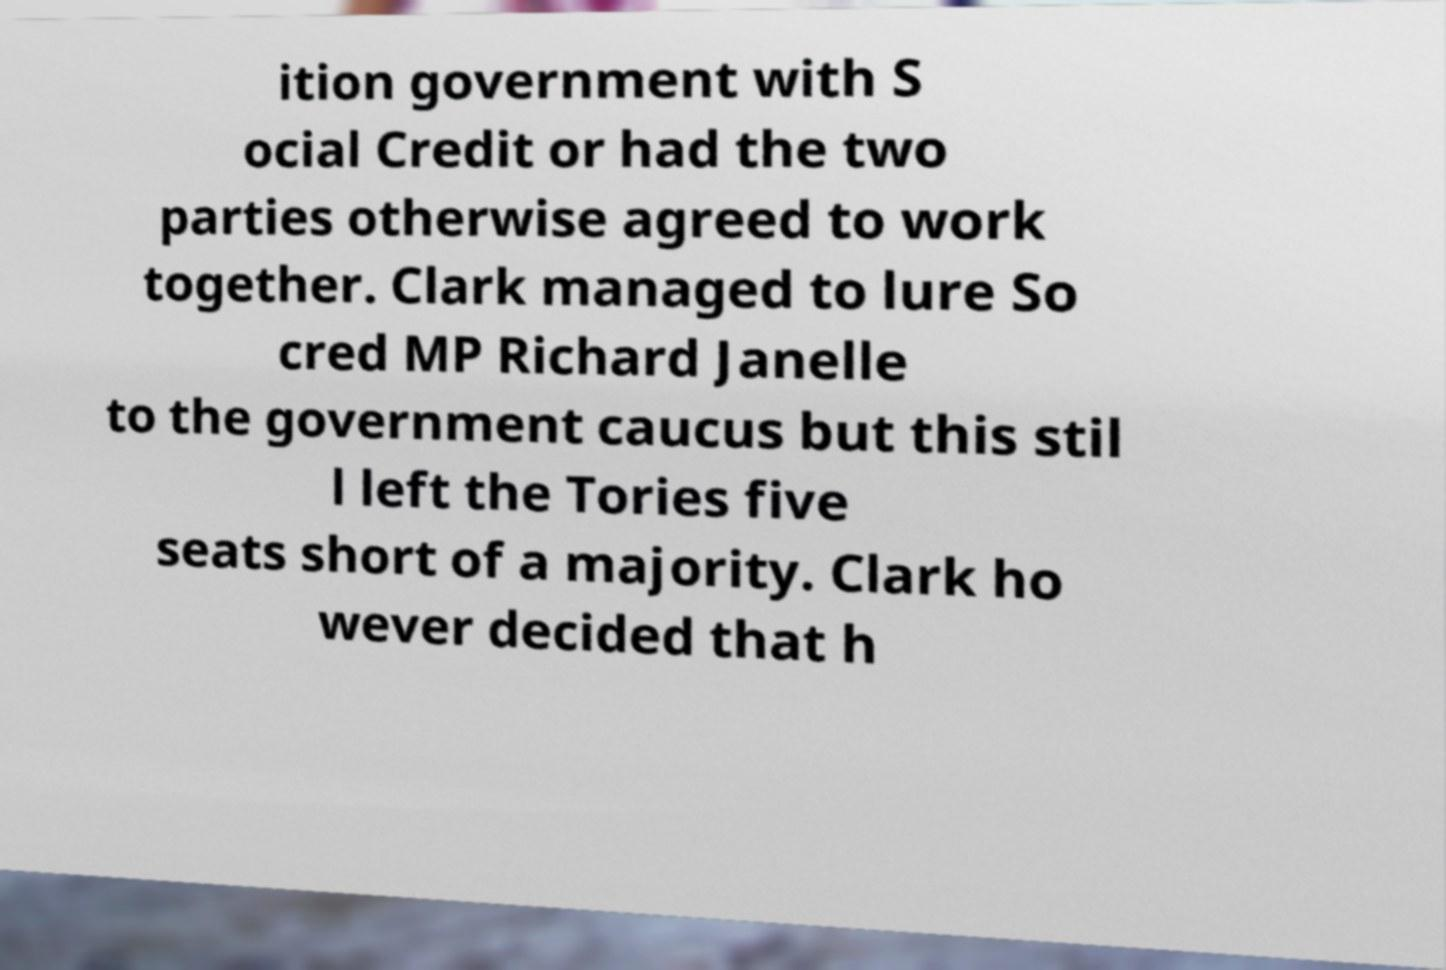I need the written content from this picture converted into text. Can you do that? ition government with S ocial Credit or had the two parties otherwise agreed to work together. Clark managed to lure So cred MP Richard Janelle to the government caucus but this stil l left the Tories five seats short of a majority. Clark ho wever decided that h 